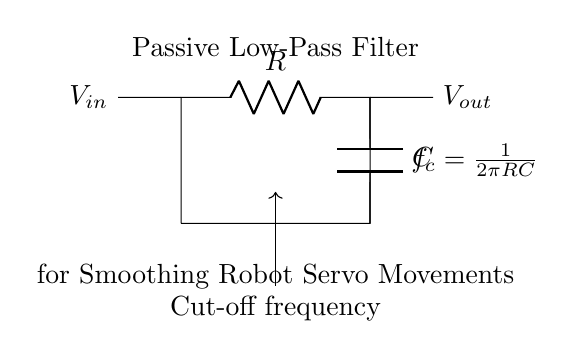What is the primary function of this circuit? The primary function of this circuit is to filter out high-frequency noise from the input signal, allowing smoother movements for the robot servo.
Answer: Smoothing What are the components used in this passive low-pass filter? The two components used in this circuit are a resistor and a capacitor. The resistor is denoted as R and the capacitor as C in the diagram.
Answer: Resistor and Capacitor What does the 'f_c' represent in the circuit? The 'f_c' in the circuit diagram represents the cut-off frequency, which determines the frequency at which the output voltage begins to decrease significantly.
Answer: Cut-off frequency Which way does the current flow in this circuit? The current flows from the input voltage (V_in), through the resistor R, and then to the capacitor C, before reaching the output voltage (V_out).
Answer: From V_in to V_out How is the cut-off frequency calculated? The cut-off frequency is calculated using the formula f_c equals one divided by two pi times the product of resistance R and capacitance C. This formula relates the component values to the frequency response of the filter.
Answer: One divided by two pi RC What happens to high-frequency signals in this filter? High-frequency signals are attenuated, meaning their amplitude is reduced significantly as they pass through the filter, allowing mostly low-frequency signals to pass through.
Answer: Attenuated What is the role of the capacitor in this circuit? The capacitor stores and releases energy, smoothing out fluctuations in the input signal and allowing only lower-frequency signals to pass through while blocking higher-frequency noise.
Answer: Smoothing out fluctuations 